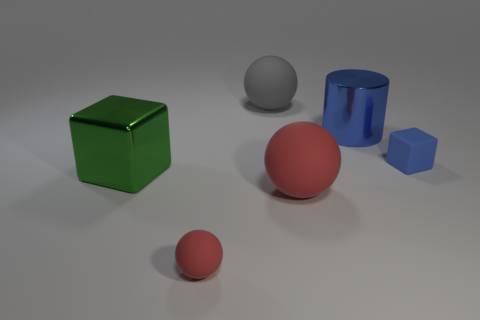Subtract all big red matte balls. How many balls are left? 2 Add 1 red matte objects. How many objects exist? 7 Subtract all gray balls. How many balls are left? 2 Subtract all cylinders. How many objects are left? 5 Add 3 large gray matte spheres. How many large gray matte spheres are left? 4 Add 6 red balls. How many red balls exist? 8 Subtract 0 blue spheres. How many objects are left? 6 Subtract 2 blocks. How many blocks are left? 0 Subtract all yellow balls. Subtract all blue cubes. How many balls are left? 3 Subtract all brown blocks. How many brown spheres are left? 0 